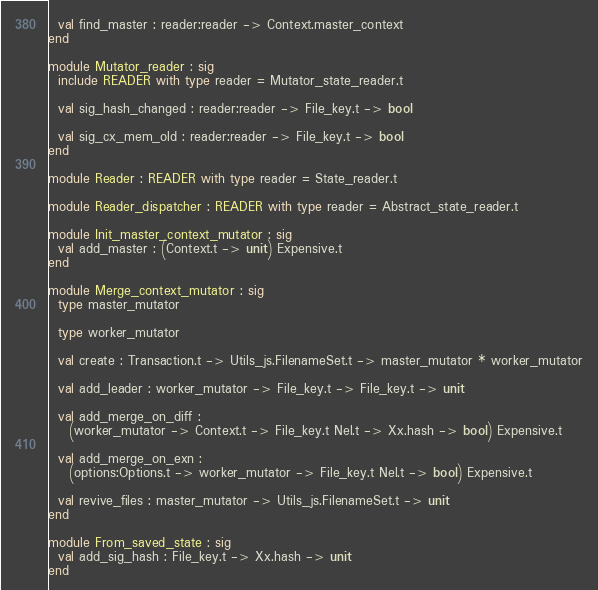<code> <loc_0><loc_0><loc_500><loc_500><_OCaml_>
  val find_master : reader:reader -> Context.master_context
end

module Mutator_reader : sig
  include READER with type reader = Mutator_state_reader.t

  val sig_hash_changed : reader:reader -> File_key.t -> bool

  val sig_cx_mem_old : reader:reader -> File_key.t -> bool
end

module Reader : READER with type reader = State_reader.t

module Reader_dispatcher : READER with type reader = Abstract_state_reader.t

module Init_master_context_mutator : sig
  val add_master : (Context.t -> unit) Expensive.t
end

module Merge_context_mutator : sig
  type master_mutator

  type worker_mutator

  val create : Transaction.t -> Utils_js.FilenameSet.t -> master_mutator * worker_mutator

  val add_leader : worker_mutator -> File_key.t -> File_key.t -> unit

  val add_merge_on_diff :
    (worker_mutator -> Context.t -> File_key.t Nel.t -> Xx.hash -> bool) Expensive.t

  val add_merge_on_exn :
    (options:Options.t -> worker_mutator -> File_key.t Nel.t -> bool) Expensive.t

  val revive_files : master_mutator -> Utils_js.FilenameSet.t -> unit
end

module From_saved_state : sig
  val add_sig_hash : File_key.t -> Xx.hash -> unit
end
</code> 